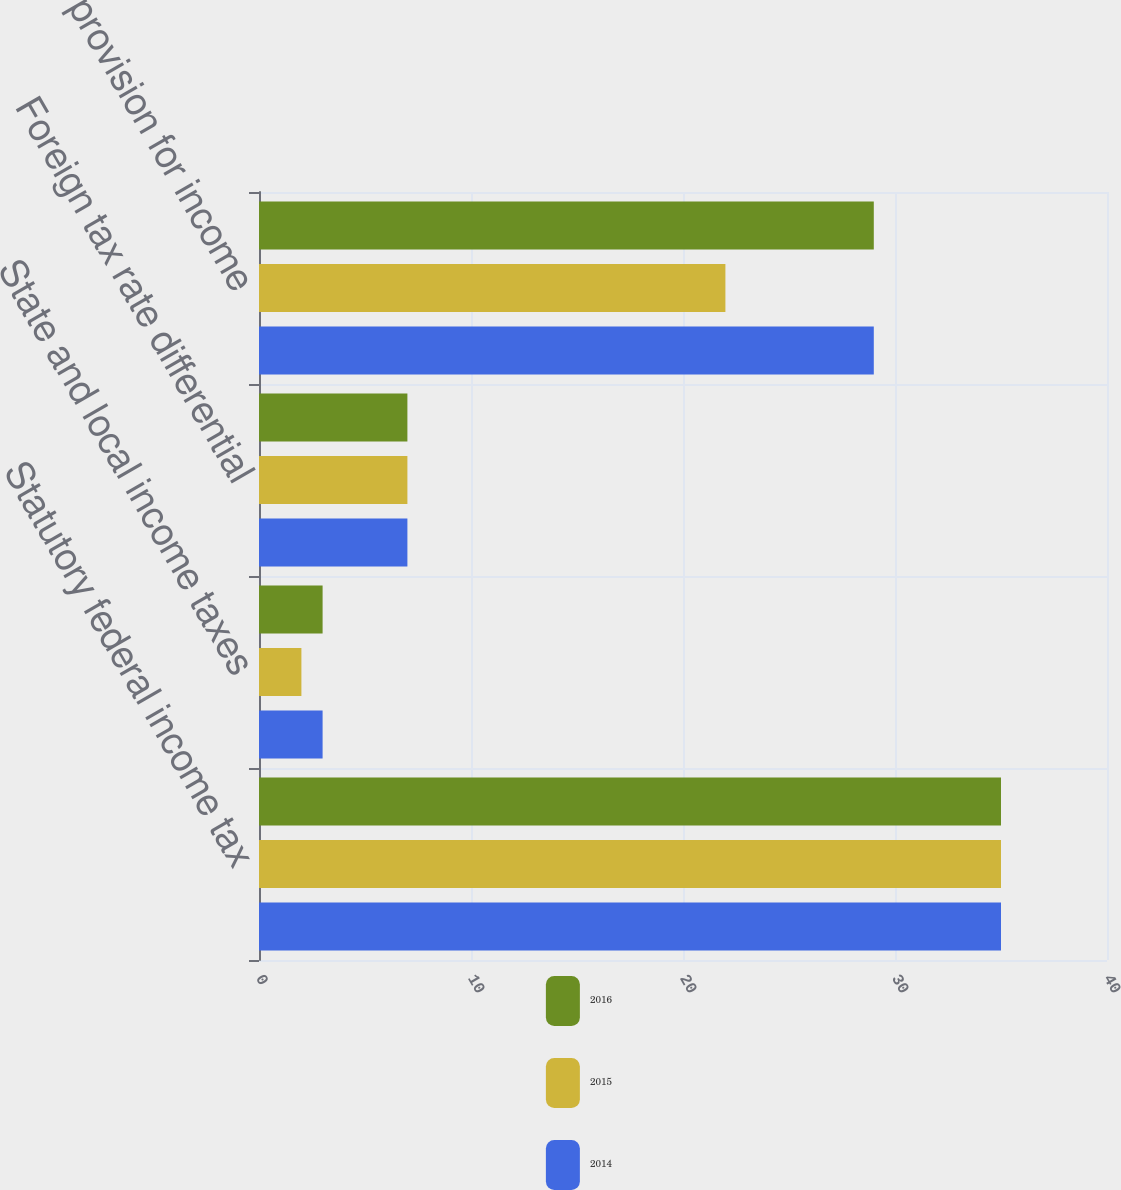<chart> <loc_0><loc_0><loc_500><loc_500><stacked_bar_chart><ecel><fcel>Statutory federal income tax<fcel>State and local income taxes<fcel>Foreign tax rate differential<fcel>Total provision for income<nl><fcel>2016<fcel>35<fcel>3<fcel>7<fcel>29<nl><fcel>2015<fcel>35<fcel>2<fcel>7<fcel>22<nl><fcel>2014<fcel>35<fcel>3<fcel>7<fcel>29<nl></chart> 